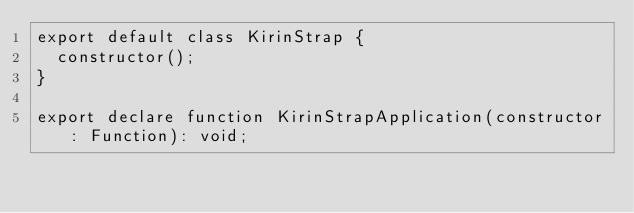Convert code to text. <code><loc_0><loc_0><loc_500><loc_500><_TypeScript_>export default class KirinStrap {
  constructor();
}

export declare function KirinStrapApplication(constructor: Function): void;
</code> 